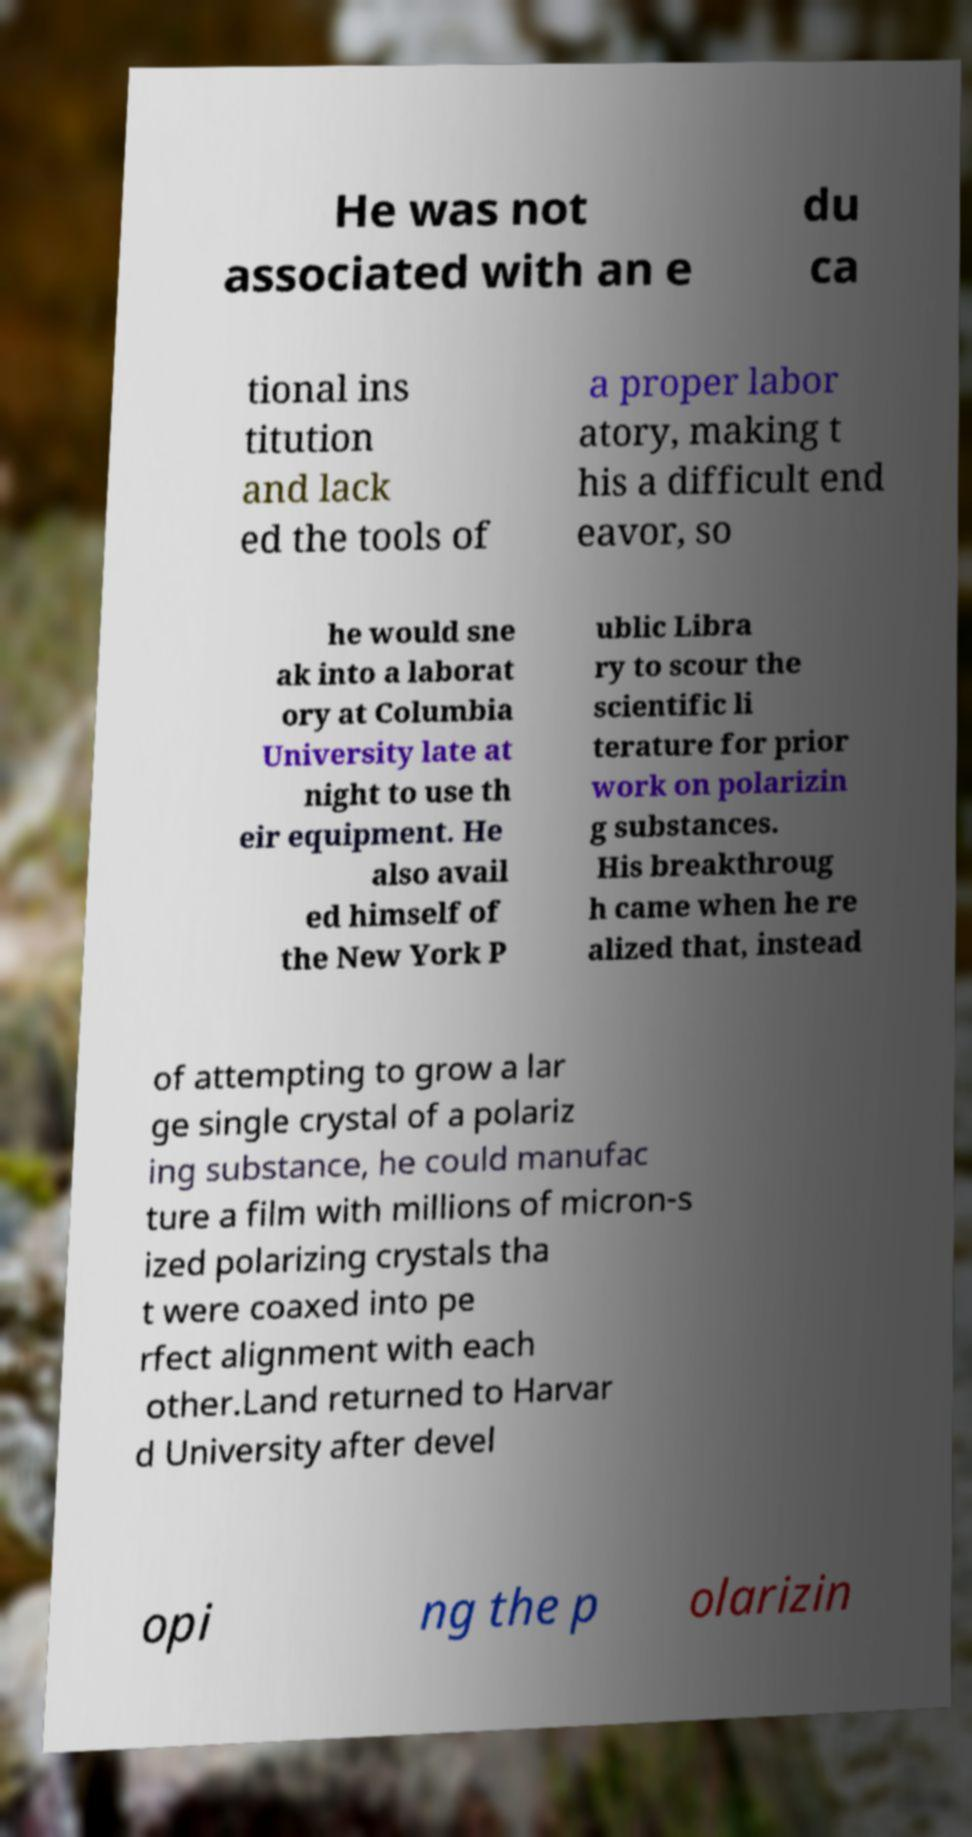Could you extract and type out the text from this image? He was not associated with an e du ca tional ins titution and lack ed the tools of a proper labor atory, making t his a difficult end eavor, so he would sne ak into a laborat ory at Columbia University late at night to use th eir equipment. He also avail ed himself of the New York P ublic Libra ry to scour the scientific li terature for prior work on polarizin g substances. His breakthroug h came when he re alized that, instead of attempting to grow a lar ge single crystal of a polariz ing substance, he could manufac ture a film with millions of micron-s ized polarizing crystals tha t were coaxed into pe rfect alignment with each other.Land returned to Harvar d University after devel opi ng the p olarizin 